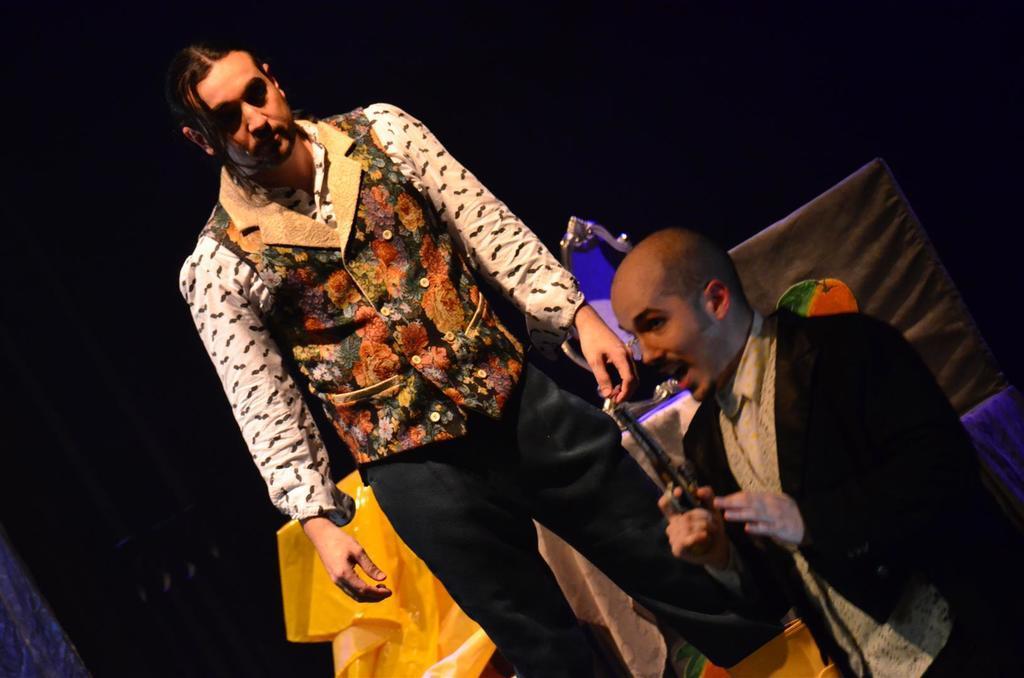Can you describe this image briefly? Here in this picture we can see two men in a different costumes standing over a place and the man in the front is speaking something with a gun in his hand, probably they are acting in a play. 